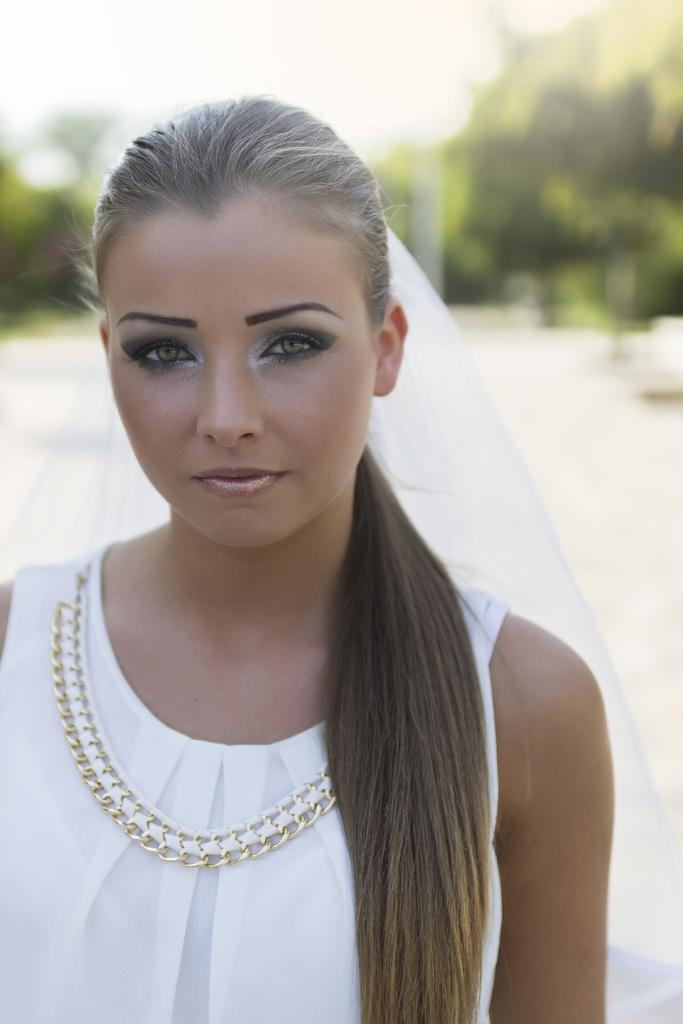Who is present in the image? There is a woman in the image. What is the woman doing in the image? The woman is standing. What is the woman wearing in the image? The woman is wearing a white dress. What can be seen in the background of the image? There are trees visible in the background of the image. What type of crayon is the woman holding in the image? There is no crayon present in the image. What type of crops is the farmer tending to in the image? There is no farmer or crops present in the image. 